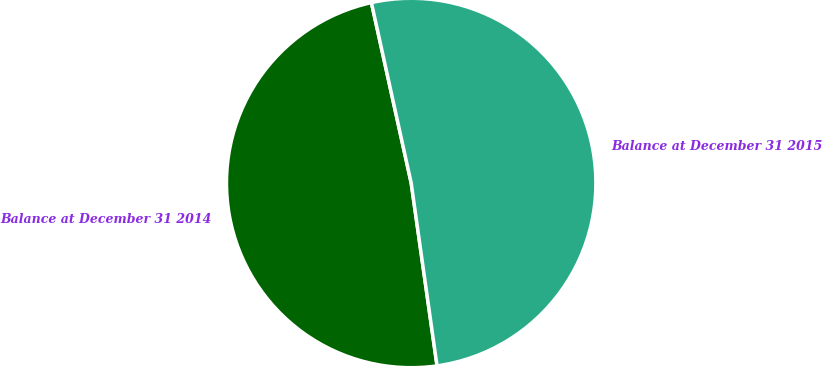Convert chart to OTSL. <chart><loc_0><loc_0><loc_500><loc_500><pie_chart><fcel>Balance at December 31 2014<fcel>Balance at December 31 2015<nl><fcel>48.78%<fcel>51.22%<nl></chart> 